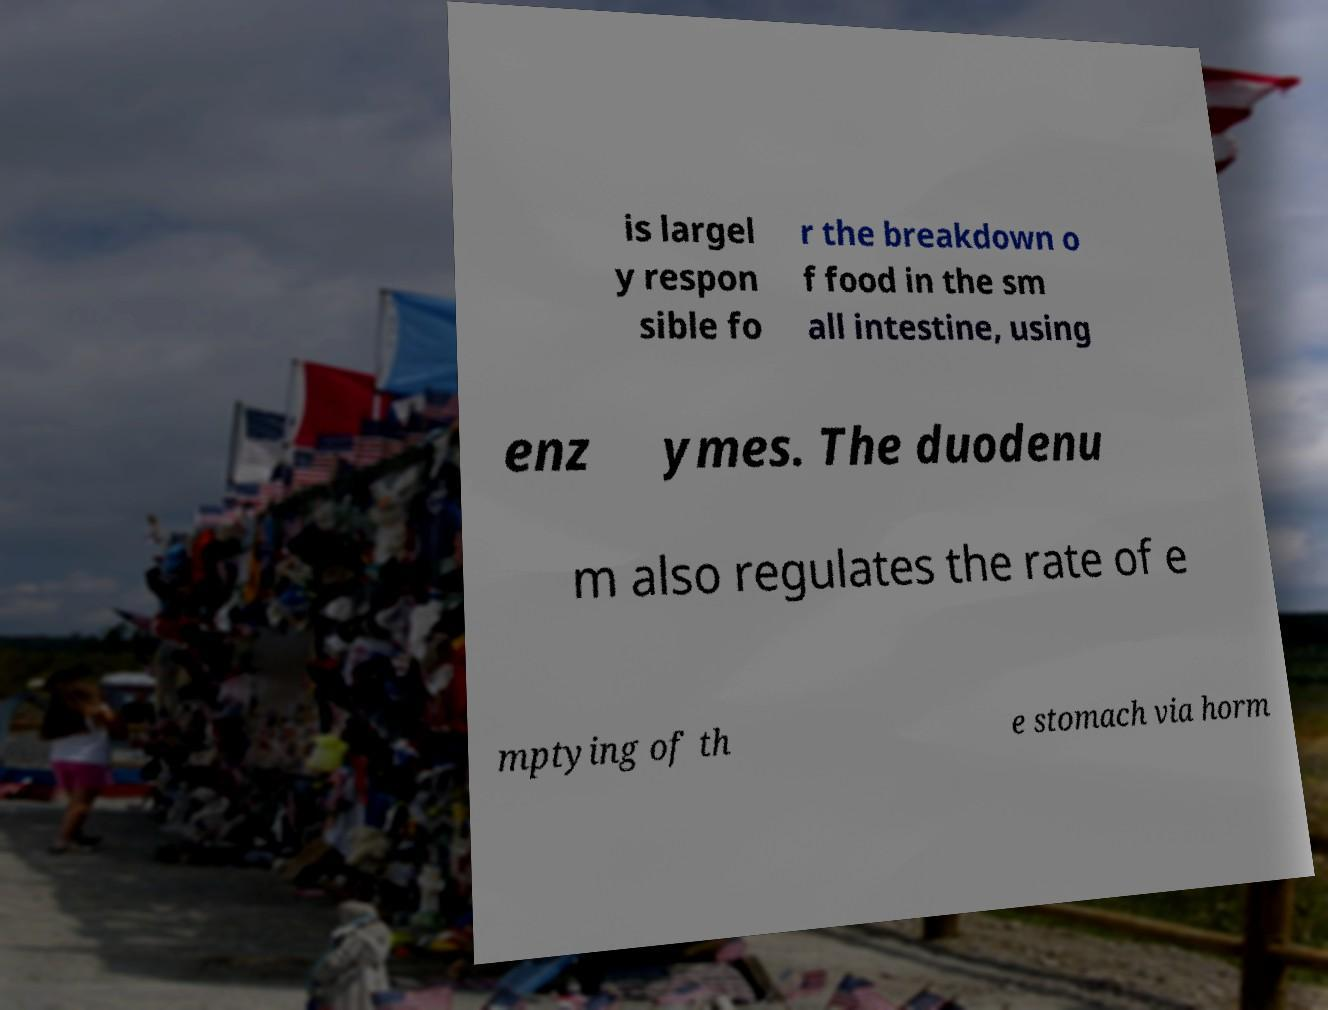Could you assist in decoding the text presented in this image and type it out clearly? is largel y respon sible fo r the breakdown o f food in the sm all intestine, using enz ymes. The duodenu m also regulates the rate of e mptying of th e stomach via horm 